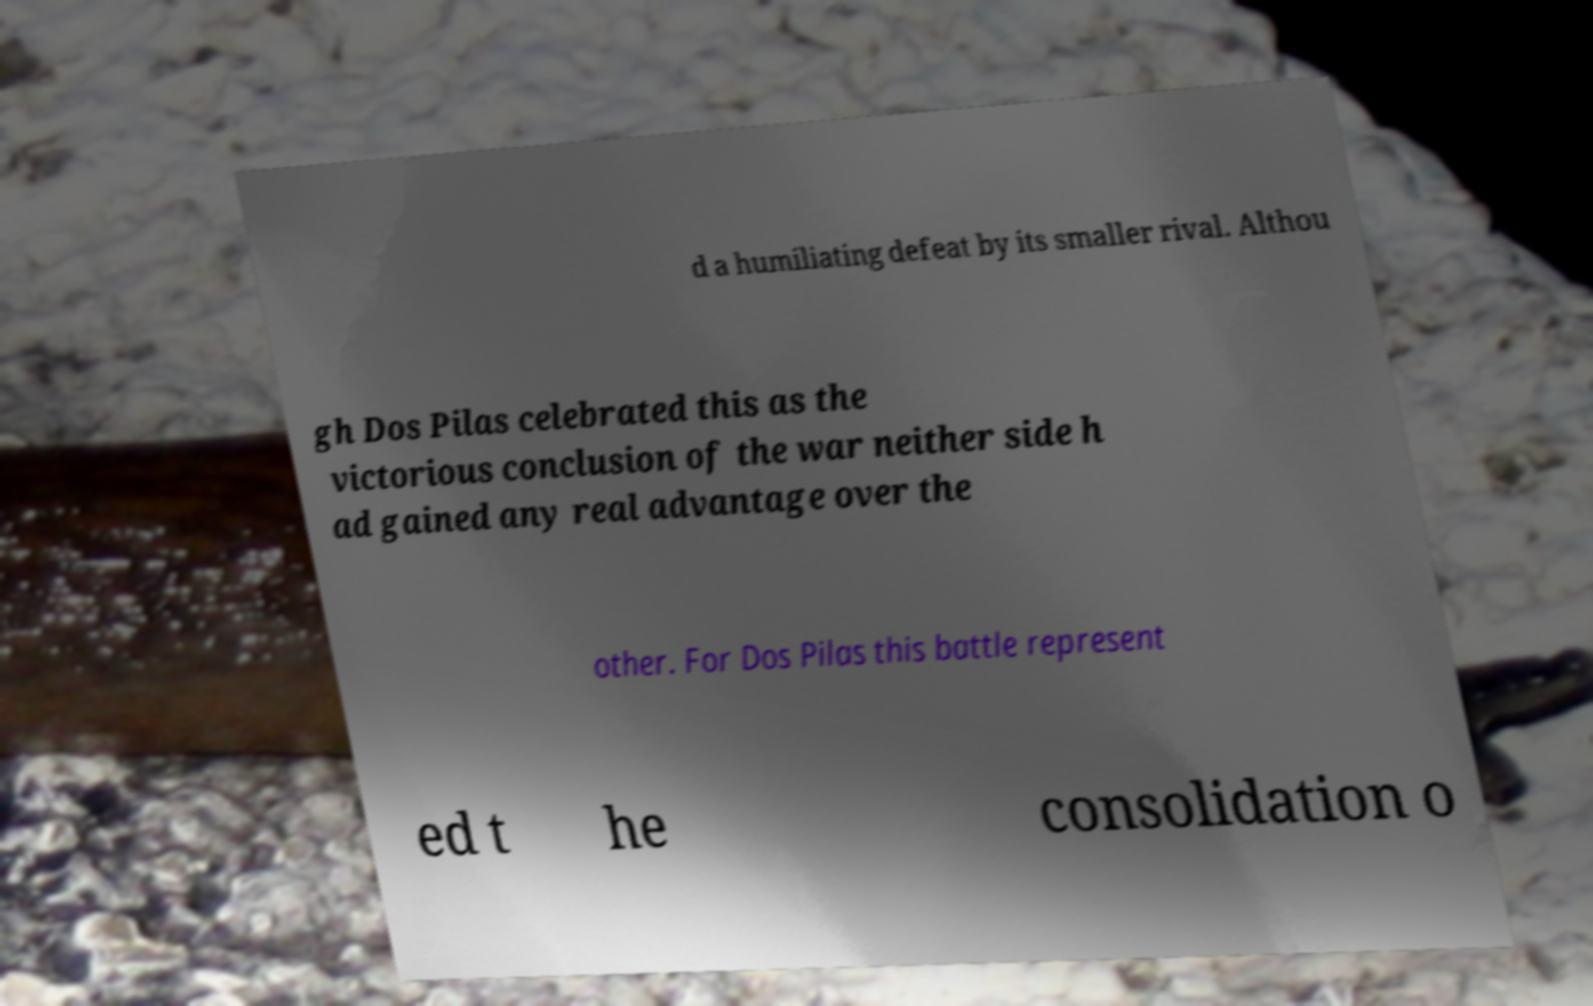Please read and relay the text visible in this image. What does it say? d a humiliating defeat by its smaller rival. Althou gh Dos Pilas celebrated this as the victorious conclusion of the war neither side h ad gained any real advantage over the other. For Dos Pilas this battle represent ed t he consolidation o 